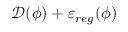Convert formula to latex. <formula><loc_0><loc_0><loc_500><loc_500>\mathcal { D } ( \phi ) + \varepsilon _ { r e g } ( \phi )</formula> 